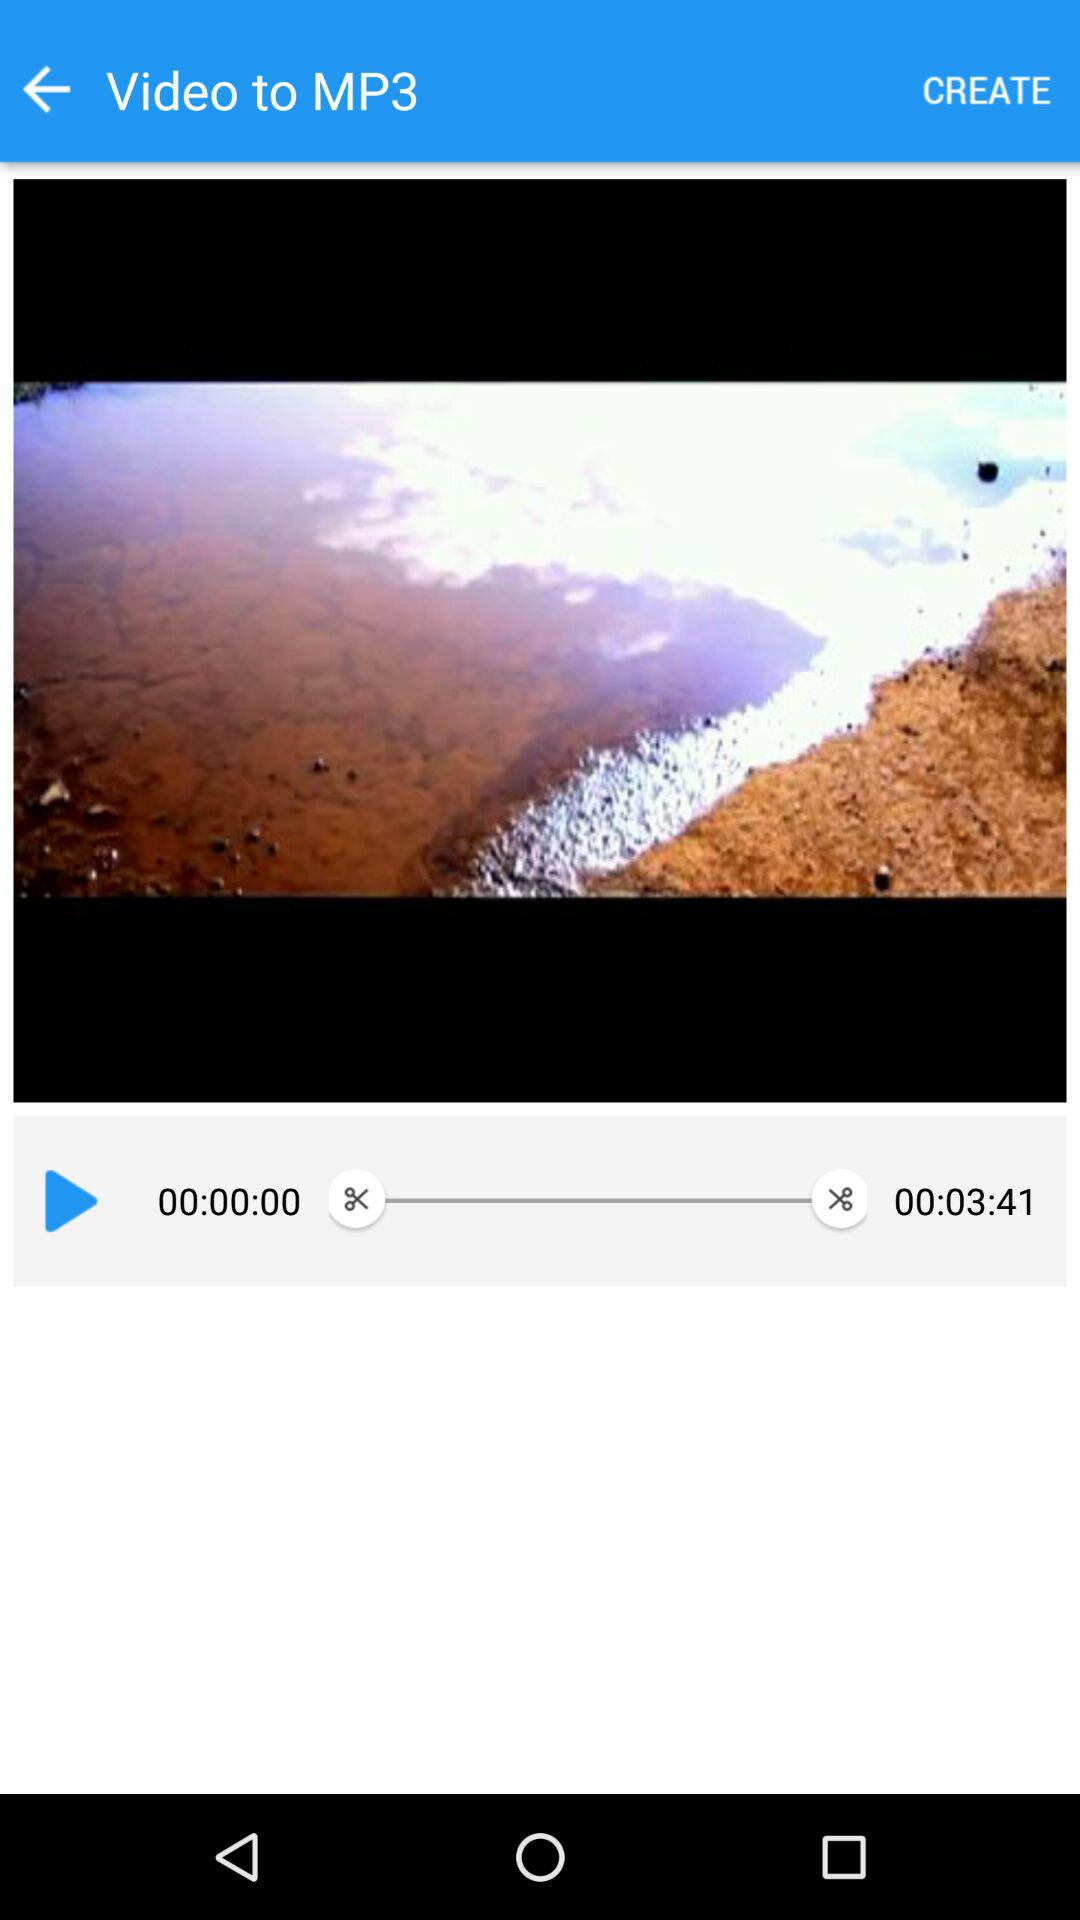What is the duration of the video? The duration of the video is 3 minutes 41 seconds. 